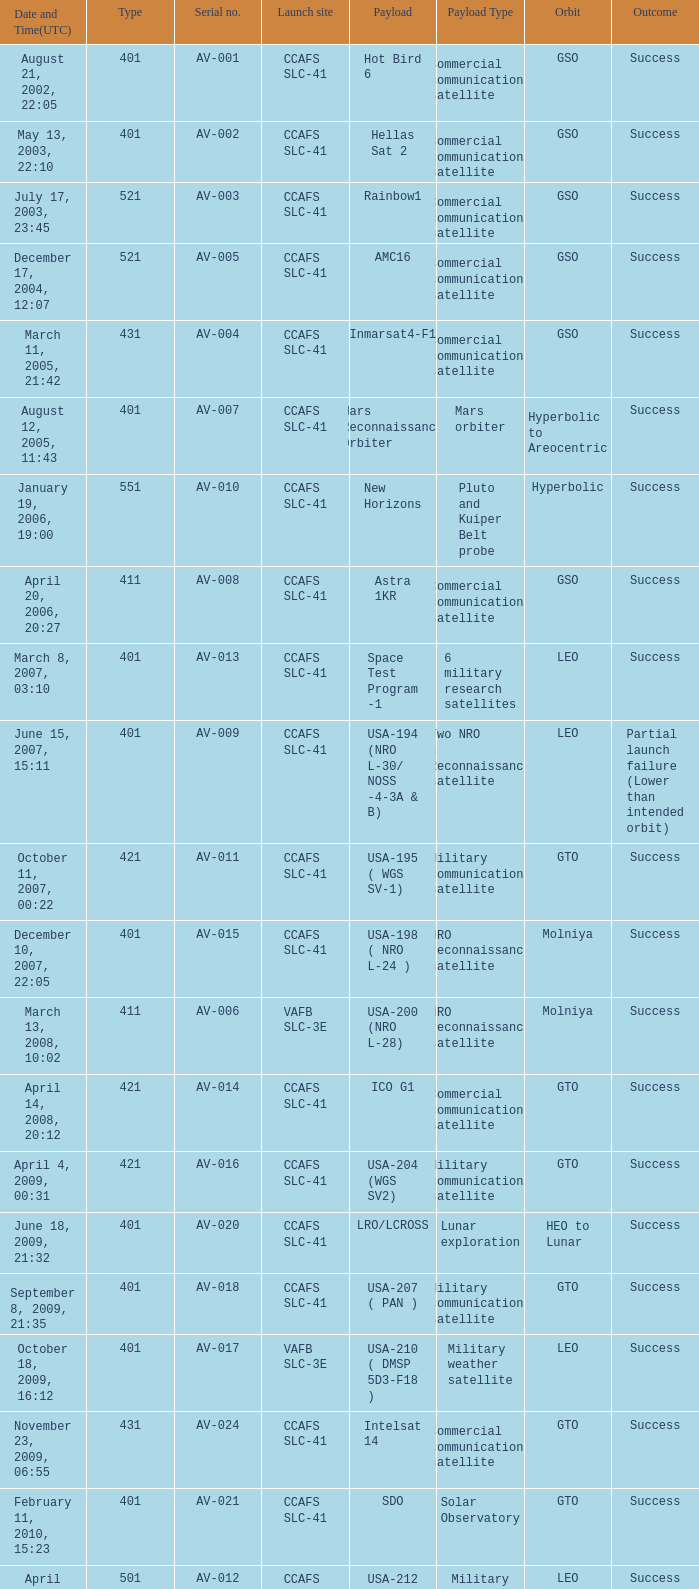When was the payload of Commercial Communications Satellite amc16? December 17, 2004, 12:07. 